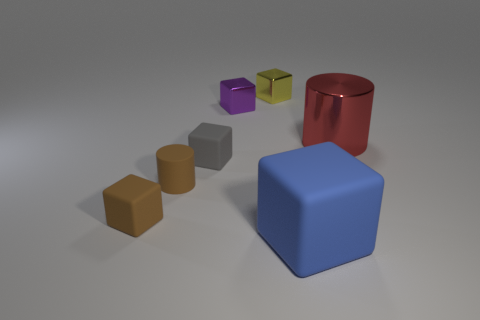Subtract all tiny gray blocks. How many blocks are left? 4 Subtract all blue cubes. How many cubes are left? 4 Add 1 rubber blocks. How many objects exist? 8 Subtract all cyan cubes. Subtract all cyan cylinders. How many cubes are left? 5 Subtract 0 purple spheres. How many objects are left? 7 Subtract all blocks. How many objects are left? 2 Subtract all big cubes. Subtract all small yellow objects. How many objects are left? 5 Add 6 gray matte objects. How many gray matte objects are left? 7 Add 3 large cylinders. How many large cylinders exist? 4 